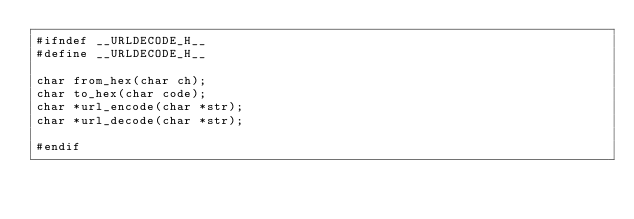<code> <loc_0><loc_0><loc_500><loc_500><_C_>#ifndef __URLDECODE_H__
#define __URLDECODE_H__

char from_hex(char ch);
char to_hex(char code);
char *url_encode(char *str);
char *url_decode(char *str);

#endif
</code> 